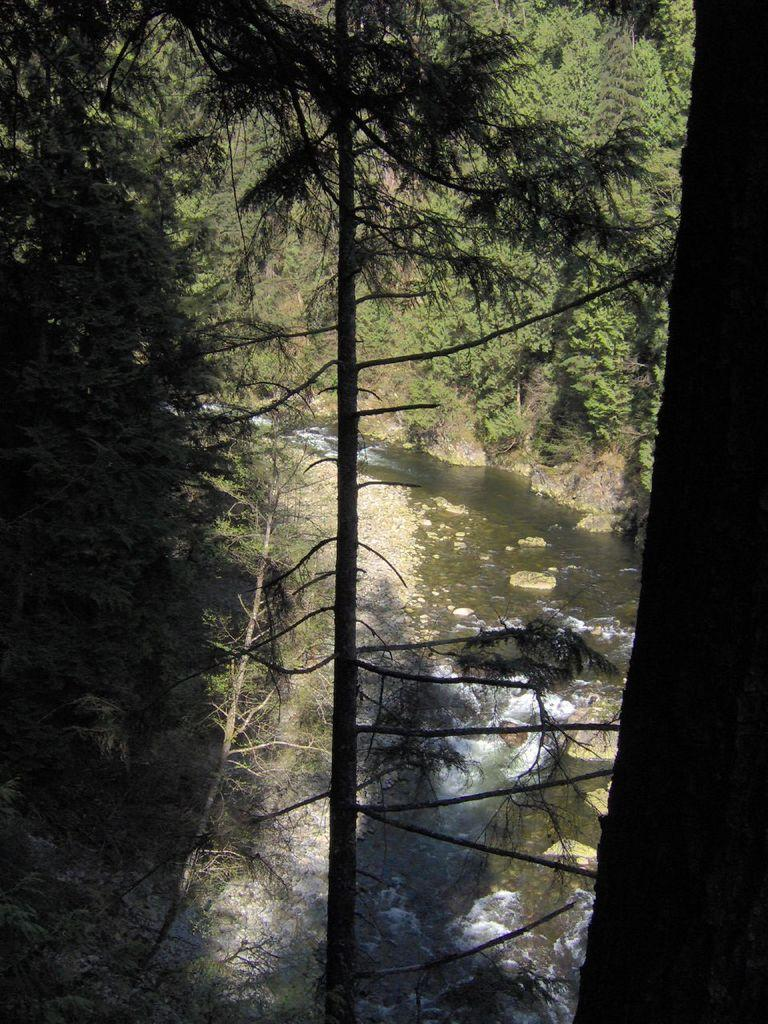What is the primary element visible in the image? There is water in the image. Are there any objects or structures placed in the water? Yes, there are rocks placed in the water. What type of vegetation can be seen near the water in the image? There are trees on either side of the water. What type of plot is being used to drain the water in the image? There is no plot or drainage system visible in the image; it simply shows water with rocks and trees. 